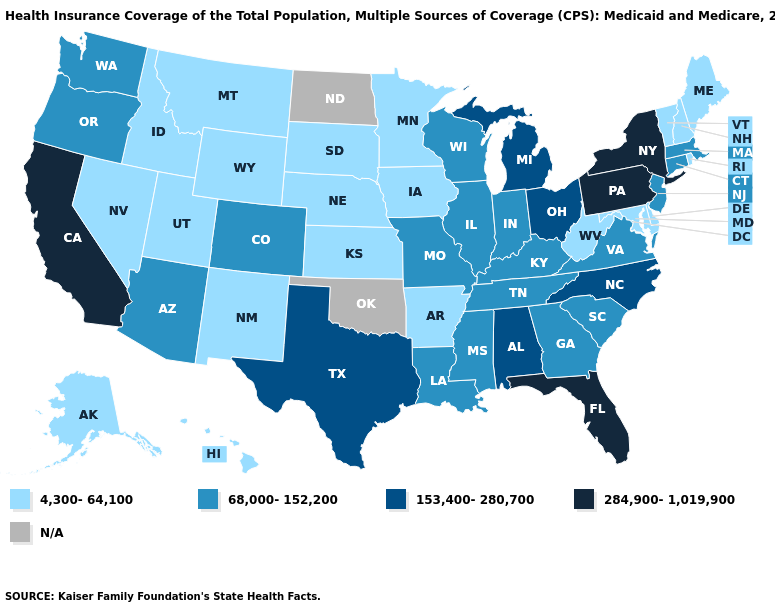Among the states that border Arkansas , which have the highest value?
Quick response, please. Texas. Name the states that have a value in the range N/A?
Be succinct. North Dakota, Oklahoma. What is the value of Delaware?
Concise answer only. 4,300-64,100. What is the value of Michigan?
Concise answer only. 153,400-280,700. Name the states that have a value in the range 4,300-64,100?
Write a very short answer. Alaska, Arkansas, Delaware, Hawaii, Idaho, Iowa, Kansas, Maine, Maryland, Minnesota, Montana, Nebraska, Nevada, New Hampshire, New Mexico, Rhode Island, South Dakota, Utah, Vermont, West Virginia, Wyoming. Name the states that have a value in the range 153,400-280,700?
Give a very brief answer. Alabama, Michigan, North Carolina, Ohio, Texas. Is the legend a continuous bar?
Concise answer only. No. Name the states that have a value in the range 284,900-1,019,900?
Quick response, please. California, Florida, New York, Pennsylvania. Name the states that have a value in the range N/A?
Be succinct. North Dakota, Oklahoma. Among the states that border Nevada , does California have the lowest value?
Quick response, please. No. How many symbols are there in the legend?
Give a very brief answer. 5. 